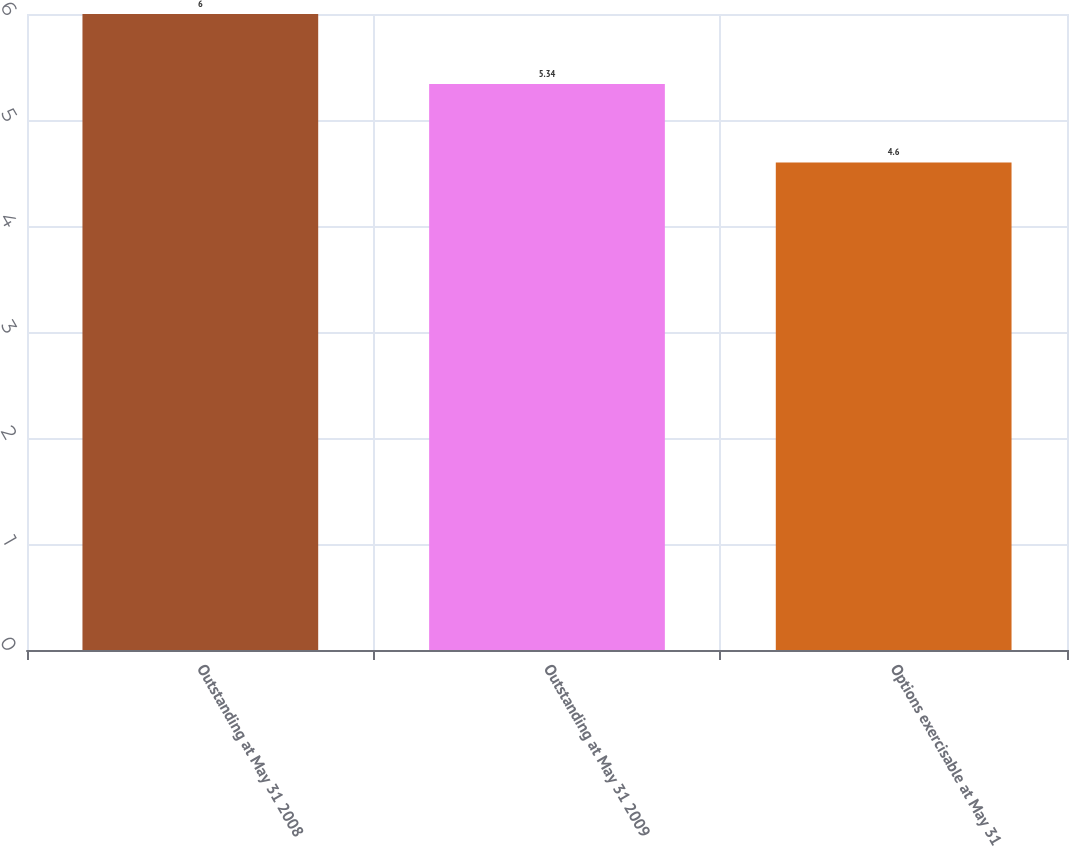Convert chart to OTSL. <chart><loc_0><loc_0><loc_500><loc_500><bar_chart><fcel>Outstanding at May 31 2008<fcel>Outstanding at May 31 2009<fcel>Options exercisable at May 31<nl><fcel>6<fcel>5.34<fcel>4.6<nl></chart> 